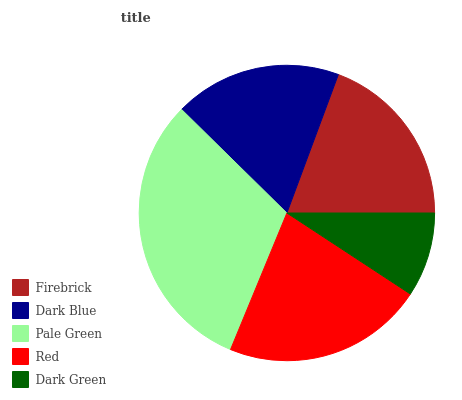Is Dark Green the minimum?
Answer yes or no. Yes. Is Pale Green the maximum?
Answer yes or no. Yes. Is Dark Blue the minimum?
Answer yes or no. No. Is Dark Blue the maximum?
Answer yes or no. No. Is Firebrick greater than Dark Blue?
Answer yes or no. Yes. Is Dark Blue less than Firebrick?
Answer yes or no. Yes. Is Dark Blue greater than Firebrick?
Answer yes or no. No. Is Firebrick less than Dark Blue?
Answer yes or no. No. Is Firebrick the high median?
Answer yes or no. Yes. Is Firebrick the low median?
Answer yes or no. Yes. Is Dark Blue the high median?
Answer yes or no. No. Is Red the low median?
Answer yes or no. No. 